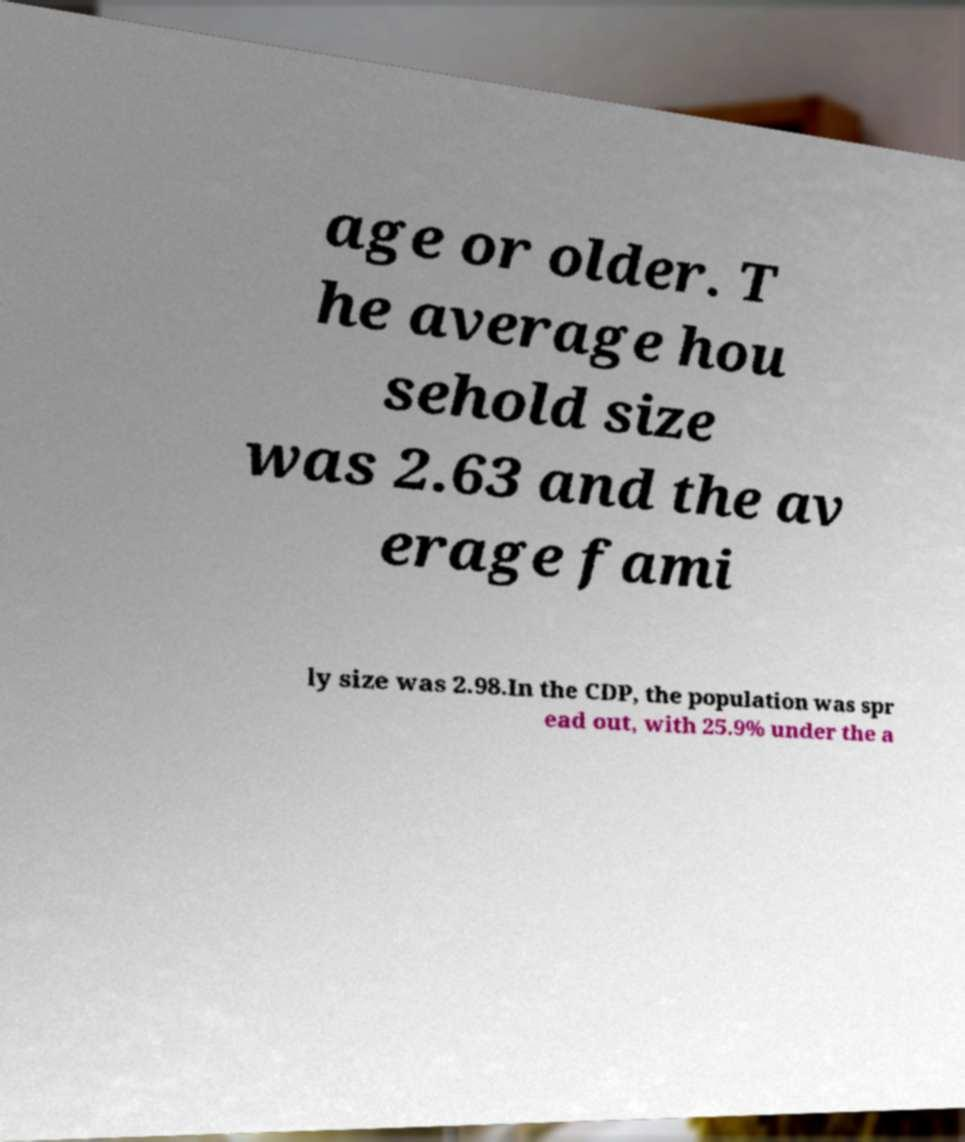Could you assist in decoding the text presented in this image and type it out clearly? age or older. T he average hou sehold size was 2.63 and the av erage fami ly size was 2.98.In the CDP, the population was spr ead out, with 25.9% under the a 